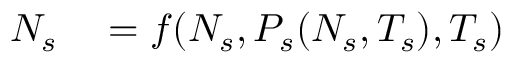Convert formula to latex. <formula><loc_0><loc_0><loc_500><loc_500>\begin{array} { r l } { N _ { s } } & = f ( N _ { s } , P _ { s } ( N _ { s } , T _ { s } ) , T _ { s } ) } \end{array}</formula> 